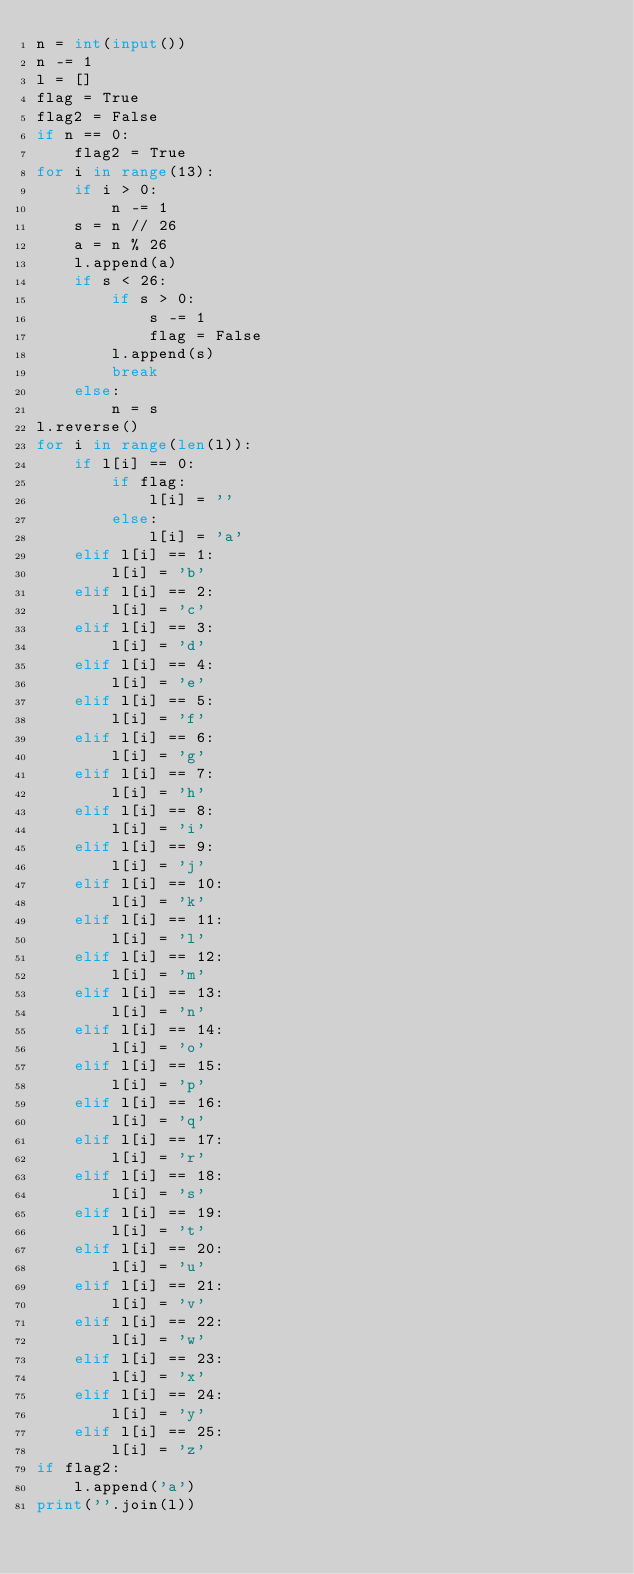<code> <loc_0><loc_0><loc_500><loc_500><_Python_>n = int(input())
n -= 1
l = []
flag = True
flag2 = False
if n == 0:
    flag2 = True
for i in range(13):
    if i > 0:
        n -= 1
    s = n // 26
    a = n % 26
    l.append(a)
    if s < 26:
        if s > 0:
            s -= 1
            flag = False
        l.append(s)
        break
    else:
        n = s
l.reverse()
for i in range(len(l)):
    if l[i] == 0:
        if flag:
            l[i] = ''
        else:
            l[i] = 'a'
    elif l[i] == 1:
        l[i] = 'b'
    elif l[i] == 2:
        l[i] = 'c'
    elif l[i] == 3:
        l[i] = 'd'
    elif l[i] == 4:
        l[i] = 'e'
    elif l[i] == 5:
        l[i] = 'f'
    elif l[i] == 6:
        l[i] = 'g'
    elif l[i] == 7:
        l[i] = 'h'
    elif l[i] == 8:
        l[i] = 'i'
    elif l[i] == 9:
        l[i] = 'j'
    elif l[i] == 10:
        l[i] = 'k'
    elif l[i] == 11:
        l[i] = 'l'
    elif l[i] == 12:
        l[i] = 'm'
    elif l[i] == 13:
        l[i] = 'n'
    elif l[i] == 14:
        l[i] = 'o'
    elif l[i] == 15:
        l[i] = 'p'
    elif l[i] == 16:
        l[i] = 'q'
    elif l[i] == 17:
        l[i] = 'r'
    elif l[i] == 18:
        l[i] = 's'
    elif l[i] == 19:
        l[i] = 't'
    elif l[i] == 20:
        l[i] = 'u'
    elif l[i] == 21:
        l[i] = 'v'
    elif l[i] == 22:
        l[i] = 'w'
    elif l[i] == 23:
        l[i] = 'x'
    elif l[i] == 24:
        l[i] = 'y'
    elif l[i] == 25:
        l[i] = 'z'
if flag2:
    l.append('a')
print(''.join(l))</code> 